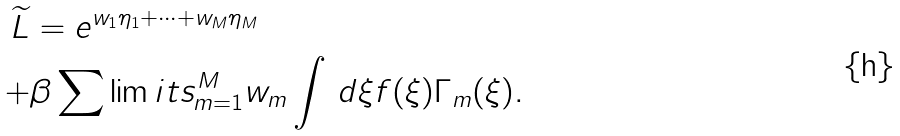Convert formula to latex. <formula><loc_0><loc_0><loc_500><loc_500>\widetilde { L } & = e ^ { w _ { 1 } \eta _ { 1 } + \dots + w _ { M } \eta _ { M } } \\ + & \beta \sum \lim i t s _ { m = 1 } ^ { M } w _ { m } \int \, d \xi f ( \xi ) \Gamma _ { m } ( \xi ) .</formula> 